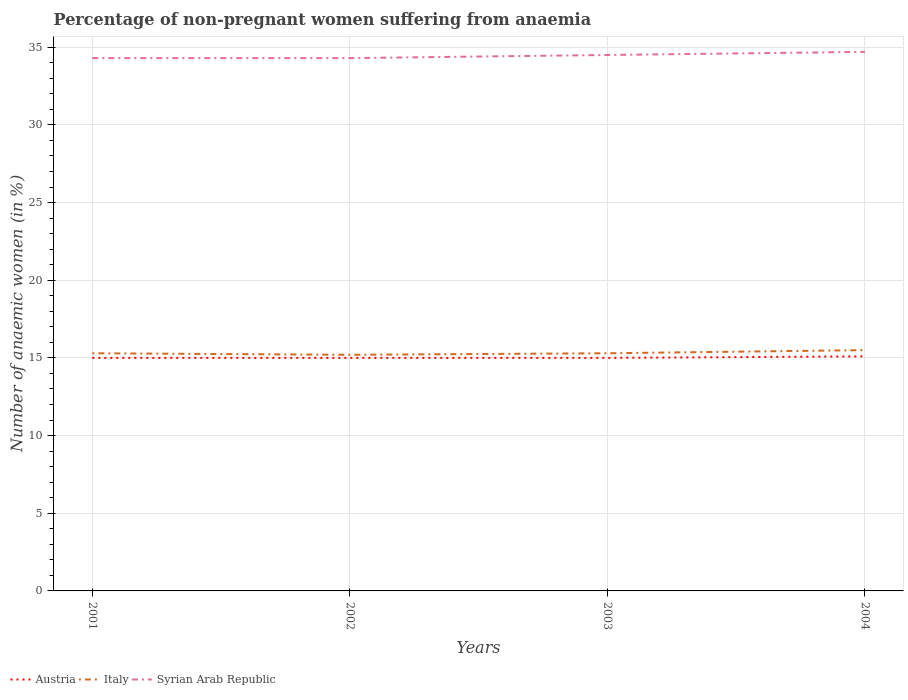How many different coloured lines are there?
Your response must be concise. 3. Does the line corresponding to Austria intersect with the line corresponding to Italy?
Your answer should be compact. No. Across all years, what is the maximum percentage of non-pregnant women suffering from anaemia in Syrian Arab Republic?
Offer a very short reply. 34.3. What is the total percentage of non-pregnant women suffering from anaemia in Syrian Arab Republic in the graph?
Ensure brevity in your answer.  -0.2. What is the difference between the highest and the second highest percentage of non-pregnant women suffering from anaemia in Italy?
Make the answer very short. 0.3. What is the difference between the highest and the lowest percentage of non-pregnant women suffering from anaemia in Italy?
Ensure brevity in your answer.  1. How many lines are there?
Make the answer very short. 3. What is the difference between two consecutive major ticks on the Y-axis?
Keep it short and to the point. 5. Does the graph contain any zero values?
Make the answer very short. No. Does the graph contain grids?
Offer a very short reply. Yes. Where does the legend appear in the graph?
Your answer should be very brief. Bottom left. How many legend labels are there?
Give a very brief answer. 3. How are the legend labels stacked?
Your answer should be compact. Horizontal. What is the title of the graph?
Make the answer very short. Percentage of non-pregnant women suffering from anaemia. Does "Liechtenstein" appear as one of the legend labels in the graph?
Offer a very short reply. No. What is the label or title of the Y-axis?
Provide a succinct answer. Number of anaemic women (in %). What is the Number of anaemic women (in %) of Austria in 2001?
Keep it short and to the point. 15. What is the Number of anaemic women (in %) of Italy in 2001?
Provide a succinct answer. 15.3. What is the Number of anaemic women (in %) of Syrian Arab Republic in 2001?
Provide a succinct answer. 34.3. What is the Number of anaemic women (in %) of Syrian Arab Republic in 2002?
Your response must be concise. 34.3. What is the Number of anaemic women (in %) of Austria in 2003?
Give a very brief answer. 15. What is the Number of anaemic women (in %) of Italy in 2003?
Keep it short and to the point. 15.3. What is the Number of anaemic women (in %) of Syrian Arab Republic in 2003?
Your response must be concise. 34.5. What is the Number of anaemic women (in %) of Austria in 2004?
Provide a succinct answer. 15.1. What is the Number of anaemic women (in %) of Syrian Arab Republic in 2004?
Your response must be concise. 34.7. Across all years, what is the maximum Number of anaemic women (in %) of Austria?
Your response must be concise. 15.1. Across all years, what is the maximum Number of anaemic women (in %) in Syrian Arab Republic?
Give a very brief answer. 34.7. Across all years, what is the minimum Number of anaemic women (in %) in Austria?
Provide a short and direct response. 15. Across all years, what is the minimum Number of anaemic women (in %) in Syrian Arab Republic?
Keep it short and to the point. 34.3. What is the total Number of anaemic women (in %) of Austria in the graph?
Give a very brief answer. 60.1. What is the total Number of anaemic women (in %) of Italy in the graph?
Give a very brief answer. 61.3. What is the total Number of anaemic women (in %) in Syrian Arab Republic in the graph?
Make the answer very short. 137.8. What is the difference between the Number of anaemic women (in %) of Austria in 2001 and that in 2002?
Give a very brief answer. 0. What is the difference between the Number of anaemic women (in %) in Syrian Arab Republic in 2001 and that in 2002?
Your answer should be compact. 0. What is the difference between the Number of anaemic women (in %) of Italy in 2001 and that in 2003?
Provide a succinct answer. 0. What is the difference between the Number of anaemic women (in %) in Syrian Arab Republic in 2001 and that in 2004?
Give a very brief answer. -0.4. What is the difference between the Number of anaemic women (in %) of Austria in 2002 and that in 2003?
Provide a succinct answer. 0. What is the difference between the Number of anaemic women (in %) of Italy in 2002 and that in 2003?
Offer a terse response. -0.1. What is the difference between the Number of anaemic women (in %) of Syrian Arab Republic in 2002 and that in 2003?
Your answer should be compact. -0.2. What is the difference between the Number of anaemic women (in %) of Syrian Arab Republic in 2002 and that in 2004?
Offer a very short reply. -0.4. What is the difference between the Number of anaemic women (in %) in Italy in 2003 and that in 2004?
Your answer should be very brief. -0.2. What is the difference between the Number of anaemic women (in %) of Syrian Arab Republic in 2003 and that in 2004?
Keep it short and to the point. -0.2. What is the difference between the Number of anaemic women (in %) in Austria in 2001 and the Number of anaemic women (in %) in Syrian Arab Republic in 2002?
Provide a short and direct response. -19.3. What is the difference between the Number of anaemic women (in %) in Italy in 2001 and the Number of anaemic women (in %) in Syrian Arab Republic in 2002?
Provide a succinct answer. -19. What is the difference between the Number of anaemic women (in %) of Austria in 2001 and the Number of anaemic women (in %) of Syrian Arab Republic in 2003?
Provide a succinct answer. -19.5. What is the difference between the Number of anaemic women (in %) of Italy in 2001 and the Number of anaemic women (in %) of Syrian Arab Republic in 2003?
Your answer should be compact. -19.2. What is the difference between the Number of anaemic women (in %) in Austria in 2001 and the Number of anaemic women (in %) in Italy in 2004?
Your answer should be compact. -0.5. What is the difference between the Number of anaemic women (in %) in Austria in 2001 and the Number of anaemic women (in %) in Syrian Arab Republic in 2004?
Your response must be concise. -19.7. What is the difference between the Number of anaemic women (in %) of Italy in 2001 and the Number of anaemic women (in %) of Syrian Arab Republic in 2004?
Provide a short and direct response. -19.4. What is the difference between the Number of anaemic women (in %) in Austria in 2002 and the Number of anaemic women (in %) in Syrian Arab Republic in 2003?
Provide a short and direct response. -19.5. What is the difference between the Number of anaemic women (in %) in Italy in 2002 and the Number of anaemic women (in %) in Syrian Arab Republic in 2003?
Provide a short and direct response. -19.3. What is the difference between the Number of anaemic women (in %) in Austria in 2002 and the Number of anaemic women (in %) in Italy in 2004?
Your answer should be compact. -0.5. What is the difference between the Number of anaemic women (in %) of Austria in 2002 and the Number of anaemic women (in %) of Syrian Arab Republic in 2004?
Your answer should be very brief. -19.7. What is the difference between the Number of anaemic women (in %) in Italy in 2002 and the Number of anaemic women (in %) in Syrian Arab Republic in 2004?
Offer a terse response. -19.5. What is the difference between the Number of anaemic women (in %) in Austria in 2003 and the Number of anaemic women (in %) in Italy in 2004?
Offer a very short reply. -0.5. What is the difference between the Number of anaemic women (in %) in Austria in 2003 and the Number of anaemic women (in %) in Syrian Arab Republic in 2004?
Keep it short and to the point. -19.7. What is the difference between the Number of anaemic women (in %) of Italy in 2003 and the Number of anaemic women (in %) of Syrian Arab Republic in 2004?
Give a very brief answer. -19.4. What is the average Number of anaemic women (in %) in Austria per year?
Your response must be concise. 15.03. What is the average Number of anaemic women (in %) in Italy per year?
Your answer should be compact. 15.32. What is the average Number of anaemic women (in %) of Syrian Arab Republic per year?
Make the answer very short. 34.45. In the year 2001, what is the difference between the Number of anaemic women (in %) of Austria and Number of anaemic women (in %) of Italy?
Your response must be concise. -0.3. In the year 2001, what is the difference between the Number of anaemic women (in %) in Austria and Number of anaemic women (in %) in Syrian Arab Republic?
Provide a succinct answer. -19.3. In the year 2001, what is the difference between the Number of anaemic women (in %) of Italy and Number of anaemic women (in %) of Syrian Arab Republic?
Give a very brief answer. -19. In the year 2002, what is the difference between the Number of anaemic women (in %) of Austria and Number of anaemic women (in %) of Syrian Arab Republic?
Your answer should be very brief. -19.3. In the year 2002, what is the difference between the Number of anaemic women (in %) of Italy and Number of anaemic women (in %) of Syrian Arab Republic?
Your answer should be compact. -19.1. In the year 2003, what is the difference between the Number of anaemic women (in %) of Austria and Number of anaemic women (in %) of Syrian Arab Republic?
Your answer should be very brief. -19.5. In the year 2003, what is the difference between the Number of anaemic women (in %) in Italy and Number of anaemic women (in %) in Syrian Arab Republic?
Provide a succinct answer. -19.2. In the year 2004, what is the difference between the Number of anaemic women (in %) of Austria and Number of anaemic women (in %) of Italy?
Offer a very short reply. -0.4. In the year 2004, what is the difference between the Number of anaemic women (in %) in Austria and Number of anaemic women (in %) in Syrian Arab Republic?
Give a very brief answer. -19.6. In the year 2004, what is the difference between the Number of anaemic women (in %) in Italy and Number of anaemic women (in %) in Syrian Arab Republic?
Your answer should be very brief. -19.2. What is the ratio of the Number of anaemic women (in %) of Italy in 2001 to that in 2002?
Your response must be concise. 1.01. What is the ratio of the Number of anaemic women (in %) in Syrian Arab Republic in 2001 to that in 2002?
Offer a very short reply. 1. What is the ratio of the Number of anaemic women (in %) in Austria in 2001 to that in 2003?
Ensure brevity in your answer.  1. What is the ratio of the Number of anaemic women (in %) of Italy in 2001 to that in 2003?
Your response must be concise. 1. What is the ratio of the Number of anaemic women (in %) of Syrian Arab Republic in 2001 to that in 2003?
Make the answer very short. 0.99. What is the ratio of the Number of anaemic women (in %) of Austria in 2001 to that in 2004?
Your response must be concise. 0.99. What is the ratio of the Number of anaemic women (in %) in Italy in 2001 to that in 2004?
Your answer should be compact. 0.99. What is the ratio of the Number of anaemic women (in %) in Austria in 2002 to that in 2003?
Provide a succinct answer. 1. What is the ratio of the Number of anaemic women (in %) of Syrian Arab Republic in 2002 to that in 2003?
Your answer should be very brief. 0.99. What is the ratio of the Number of anaemic women (in %) of Italy in 2002 to that in 2004?
Your answer should be compact. 0.98. What is the ratio of the Number of anaemic women (in %) in Austria in 2003 to that in 2004?
Provide a succinct answer. 0.99. What is the ratio of the Number of anaemic women (in %) of Italy in 2003 to that in 2004?
Keep it short and to the point. 0.99. What is the ratio of the Number of anaemic women (in %) in Syrian Arab Republic in 2003 to that in 2004?
Offer a very short reply. 0.99. What is the difference between the highest and the second highest Number of anaemic women (in %) of Italy?
Provide a succinct answer. 0.2. What is the difference between the highest and the second highest Number of anaemic women (in %) in Syrian Arab Republic?
Your response must be concise. 0.2. What is the difference between the highest and the lowest Number of anaemic women (in %) of Austria?
Offer a very short reply. 0.1. What is the difference between the highest and the lowest Number of anaemic women (in %) of Italy?
Give a very brief answer. 0.3. 